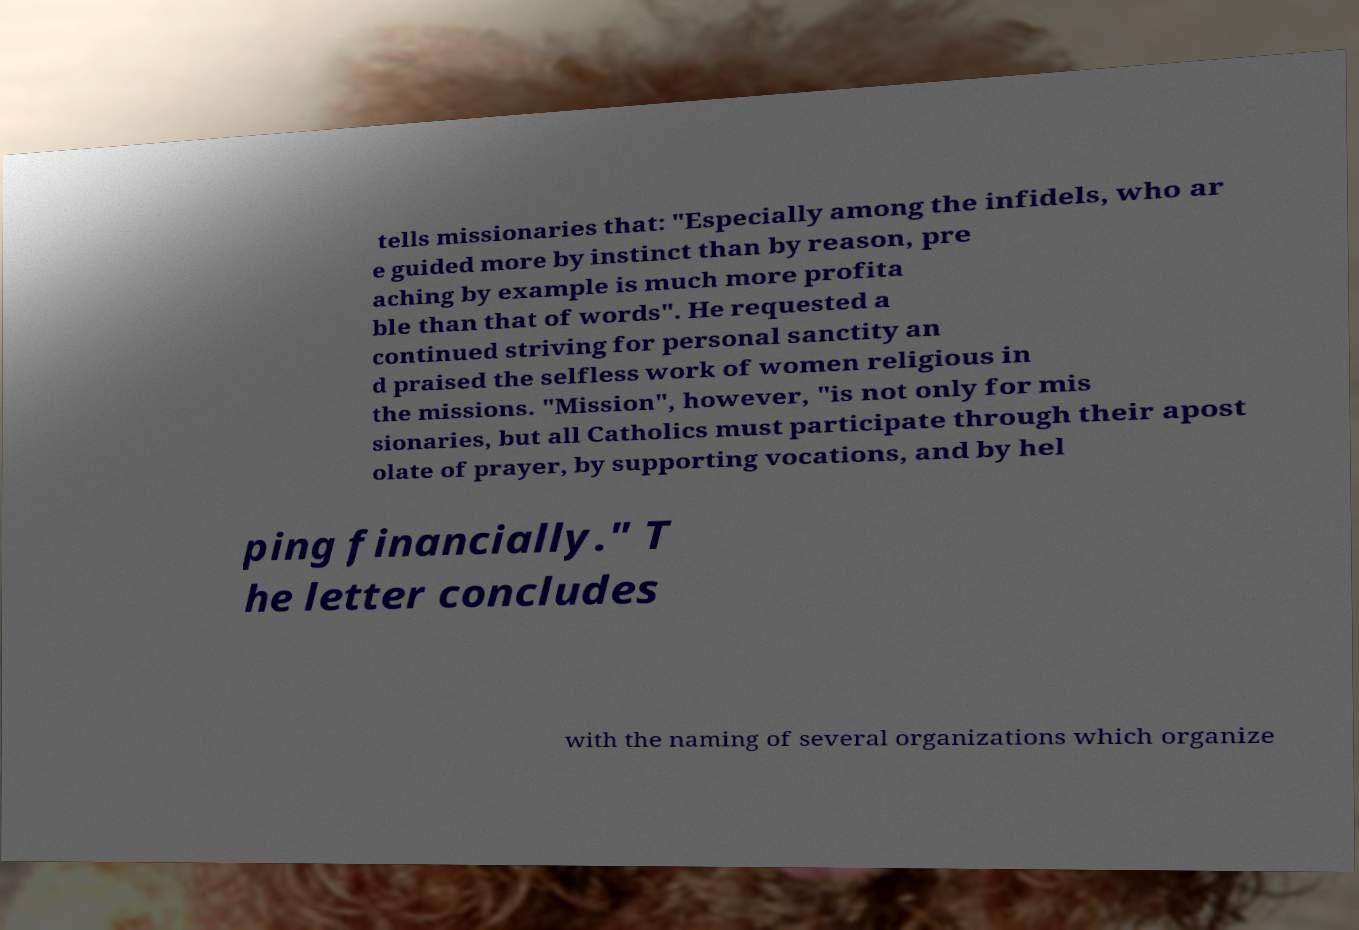There's text embedded in this image that I need extracted. Can you transcribe it verbatim? tells missionaries that: "Especially among the infidels, who ar e guided more by instinct than by reason, pre aching by example is much more profita ble than that of words". He requested a continued striving for personal sanctity an d praised the selfless work of women religious in the missions. "Mission", however, "is not only for mis sionaries, but all Catholics must participate through their apost olate of prayer, by supporting vocations, and by hel ping financially." T he letter concludes with the naming of several organizations which organize 